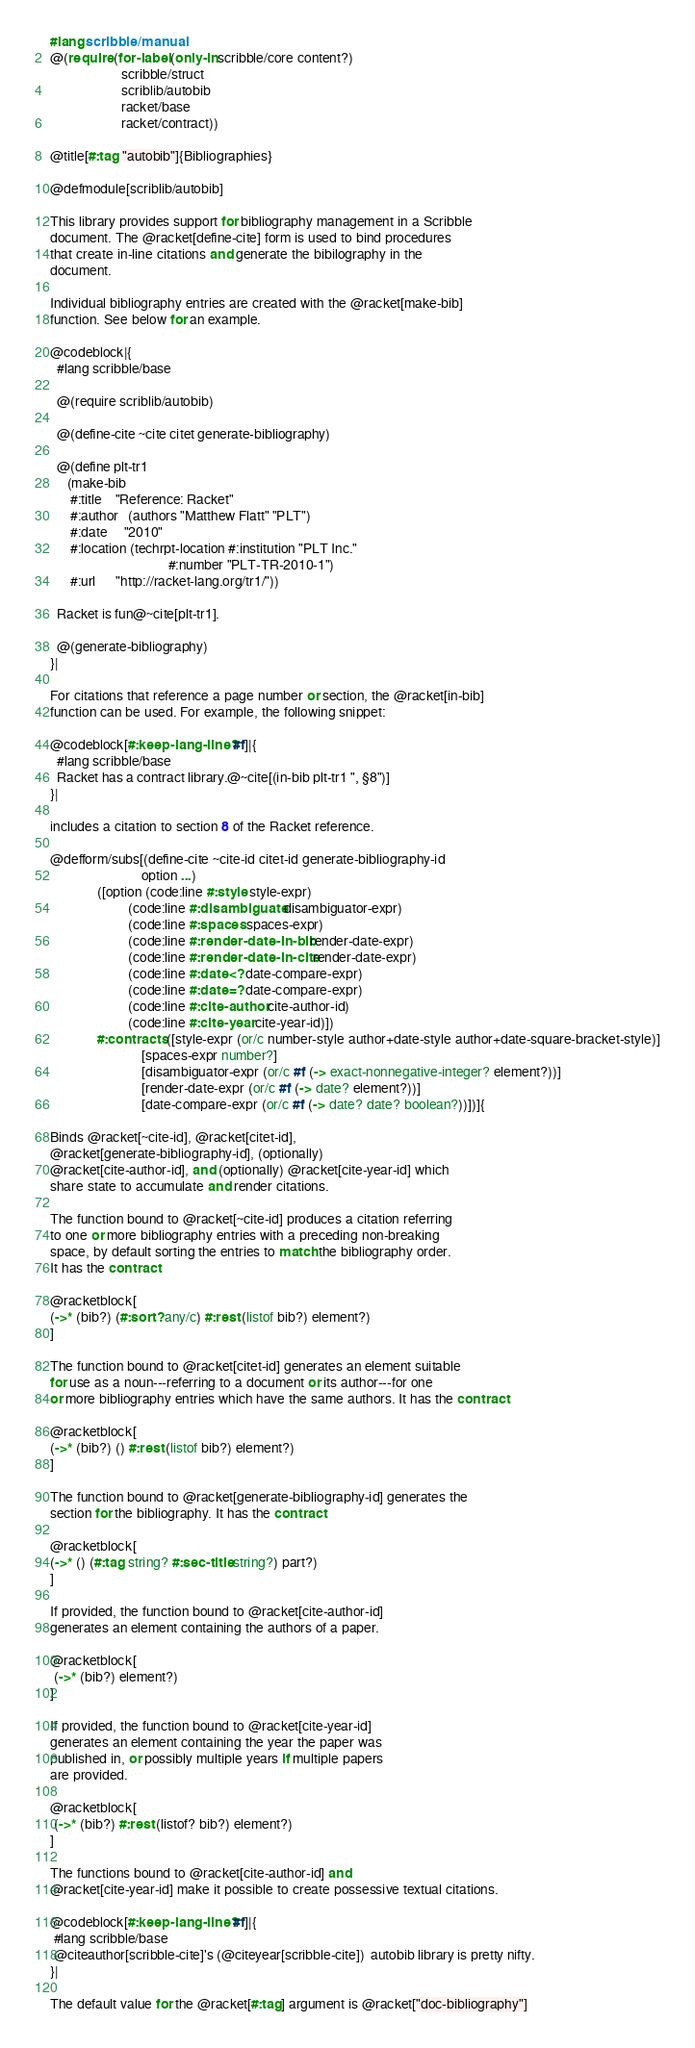Convert code to text. <code><loc_0><loc_0><loc_500><loc_500><_Racket_>#lang scribble/manual
@(require (for-label (only-in scribble/core content?)
                     scribble/struct
                     scriblib/autobib
                     racket/base
                     racket/contract))

@title[#:tag "autobib"]{Bibliographies}

@defmodule[scriblib/autobib]

This library provides support for bibliography management in a Scribble
document. The @racket[define-cite] form is used to bind procedures
that create in-line citations and generate the bibilography in the
document.

Individual bibliography entries are created with the @racket[make-bib]
function. See below for an example.

@codeblock|{
  #lang scribble/base

  @(require scriblib/autobib)

  @(define-cite ~cite citet generate-bibliography)

  @(define plt-tr1
     (make-bib
      #:title    "Reference: Racket"
      #:author   (authors "Matthew Flatt" "PLT")
      #:date     "2010"
      #:location (techrpt-location #:institution "PLT Inc." 
                                   #:number "PLT-TR-2010-1")
      #:url      "http://racket-lang.org/tr1/"))

  Racket is fun@~cite[plt-tr1].

  @(generate-bibliography)
}|

For citations that reference a page number or section, the @racket[in-bib]
function can be used. For example, the following snippet:

@codeblock[#:keep-lang-line? #f]|{
  #lang scribble/base
  Racket has a contract library.@~cite[(in-bib plt-tr1 ", §8")]
}|

includes a citation to section 8 of the Racket reference.

@defform/subs[(define-cite ~cite-id citet-id generate-bibliography-id
                           option ...)
              ([option (code:line #:style style-expr)
                       (code:line #:disambiguate disambiguator-expr)
                       (code:line #:spaces spaces-expr)
                       (code:line #:render-date-in-bib render-date-expr)
                       (code:line #:render-date-in-cite render-date-expr)
                       (code:line #:date<? date-compare-expr)
                       (code:line #:date=? date-compare-expr)
                       (code:line #:cite-author cite-author-id)
                       (code:line #:cite-year cite-year-id)])
              #:contracts ([style-expr (or/c number-style author+date-style author+date-square-bracket-style)]
                           [spaces-expr number?]
                           [disambiguator-expr (or/c #f (-> exact-nonnegative-integer? element?))]
                           [render-date-expr (or/c #f (-> date? element?))]
                           [date-compare-expr (or/c #f (-> date? date? boolean?))])]{

Binds @racket[~cite-id], @racket[citet-id],
@racket[generate-bibliography-id], (optionally)
@racket[cite-author-id], and (optionally) @racket[cite-year-id] which
share state to accumulate and render citations.

The function bound to @racket[~cite-id] produces a citation referring
to one or more bibliography entries with a preceding non-breaking
space, by default sorting the entries to match the bibliography order.
It has the contract

@racketblock[
(->* (bib?) (#:sort? any/c) #:rest (listof bib?) element?)
]

The function bound to @racket[citet-id] generates an element suitable
for use as a noun---referring to a document or its author---for one
or more bibliography entries which have the same authors. It has the contract

@racketblock[
(->* (bib?) () #:rest (listof bib?) element?)
]

The function bound to @racket[generate-bibliography-id] generates the
section for the bibliography. It has the contract

@racketblock[
(->* () (#:tag string? #:sec-title string?) part?)
]

If provided, the function bound to @racket[cite-author-id]
generates an element containing the authors of a paper.

@racketblock[
 (->* (bib?) element?)
]

If provided, the function bound to @racket[cite-year-id]
generates an element containing the year the paper was
published in, or possibly multiple years if multiple papers
are provided.

@racketblock[
 (->* (bib?) #:rest (listof? bib?) element?)
]

The functions bound to @racket[cite-author-id] and
@racket[cite-year-id] make it possible to create possessive textual citations.

@codeblock[#:keep-lang-line? #f]|{
 #lang scribble/base
 @citeauthor[scribble-cite]'s (@citeyear[scribble-cite])  autobib library is pretty nifty.
}|

The default value for the @racket[#:tag] argument is @racket["doc-bibliography"]</code> 